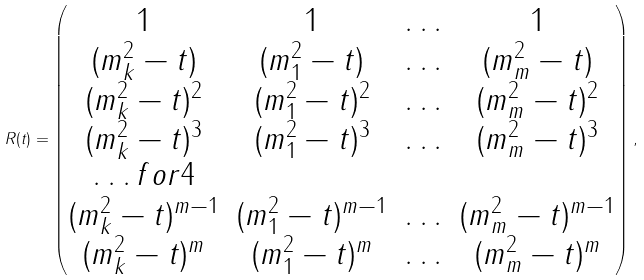Convert formula to latex. <formula><loc_0><loc_0><loc_500><loc_500>R ( t ) = \begin{pmatrix} 1 & 1 & \hdots & 1 \\ ( m _ { k } ^ { 2 } - t ) & ( m _ { 1 } ^ { 2 } - t ) & \hdots & ( m _ { m } ^ { 2 } - t ) \\ ( m _ { k } ^ { 2 } - t ) ^ { 2 } & ( m _ { 1 } ^ { 2 } - t ) ^ { 2 } & \hdots & ( m _ { m } ^ { 2 } - t ) ^ { 2 } \\ ( m _ { k } ^ { 2 } - t ) ^ { 3 } & ( m _ { 1 } ^ { 2 } - t ) ^ { 3 } & \hdots & ( m _ { m } ^ { 2 } - t ) ^ { 3 } \\ \hdots f o r 4 \\ ( m _ { k } ^ { 2 } - t ) ^ { m - 1 } & ( m _ { 1 } ^ { 2 } - t ) ^ { m - 1 } & \hdots & ( m _ { m } ^ { 2 } - t ) ^ { m - 1 } \\ ( m _ { k } ^ { 2 } - t ) ^ { m } & ( m _ { 1 } ^ { 2 } - t ) ^ { m } & \hdots & ( m _ { m } ^ { 2 } - t ) ^ { m } \\ \end{pmatrix} ,</formula> 